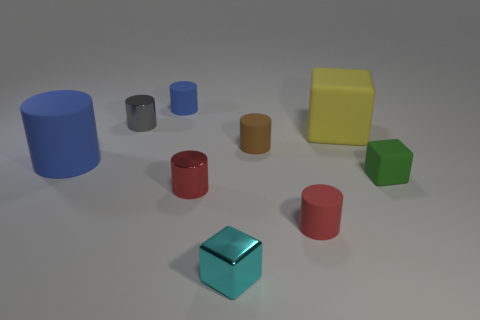What is the size of the object that is both to the left of the tiny blue cylinder and in front of the small gray metallic cylinder?
Make the answer very short. Large. There is a blue thing in front of the small brown matte cylinder right of the cyan metal block; what is its shape?
Your response must be concise. Cylinder. Are there any other things that are the same shape as the small brown matte thing?
Your answer should be very brief. Yes. Are there the same number of brown cylinders left of the gray cylinder and red rubber blocks?
Your response must be concise. Yes. There is a large cylinder; does it have the same color as the small rubber cylinder to the left of the small cyan object?
Keep it short and to the point. Yes. There is a object that is left of the red matte cylinder and to the right of the small metallic cube; what is its color?
Keep it short and to the point. Brown. There is a large yellow rubber thing on the right side of the brown cylinder; how many small metallic objects are to the right of it?
Your response must be concise. 0. Are there any tiny objects of the same shape as the large yellow thing?
Offer a terse response. Yes. Does the big object to the left of the red shiny object have the same shape as the gray thing that is to the left of the large yellow rubber block?
Your response must be concise. Yes. How many things are tiny brown rubber cylinders or blue things?
Your answer should be compact. 3. 